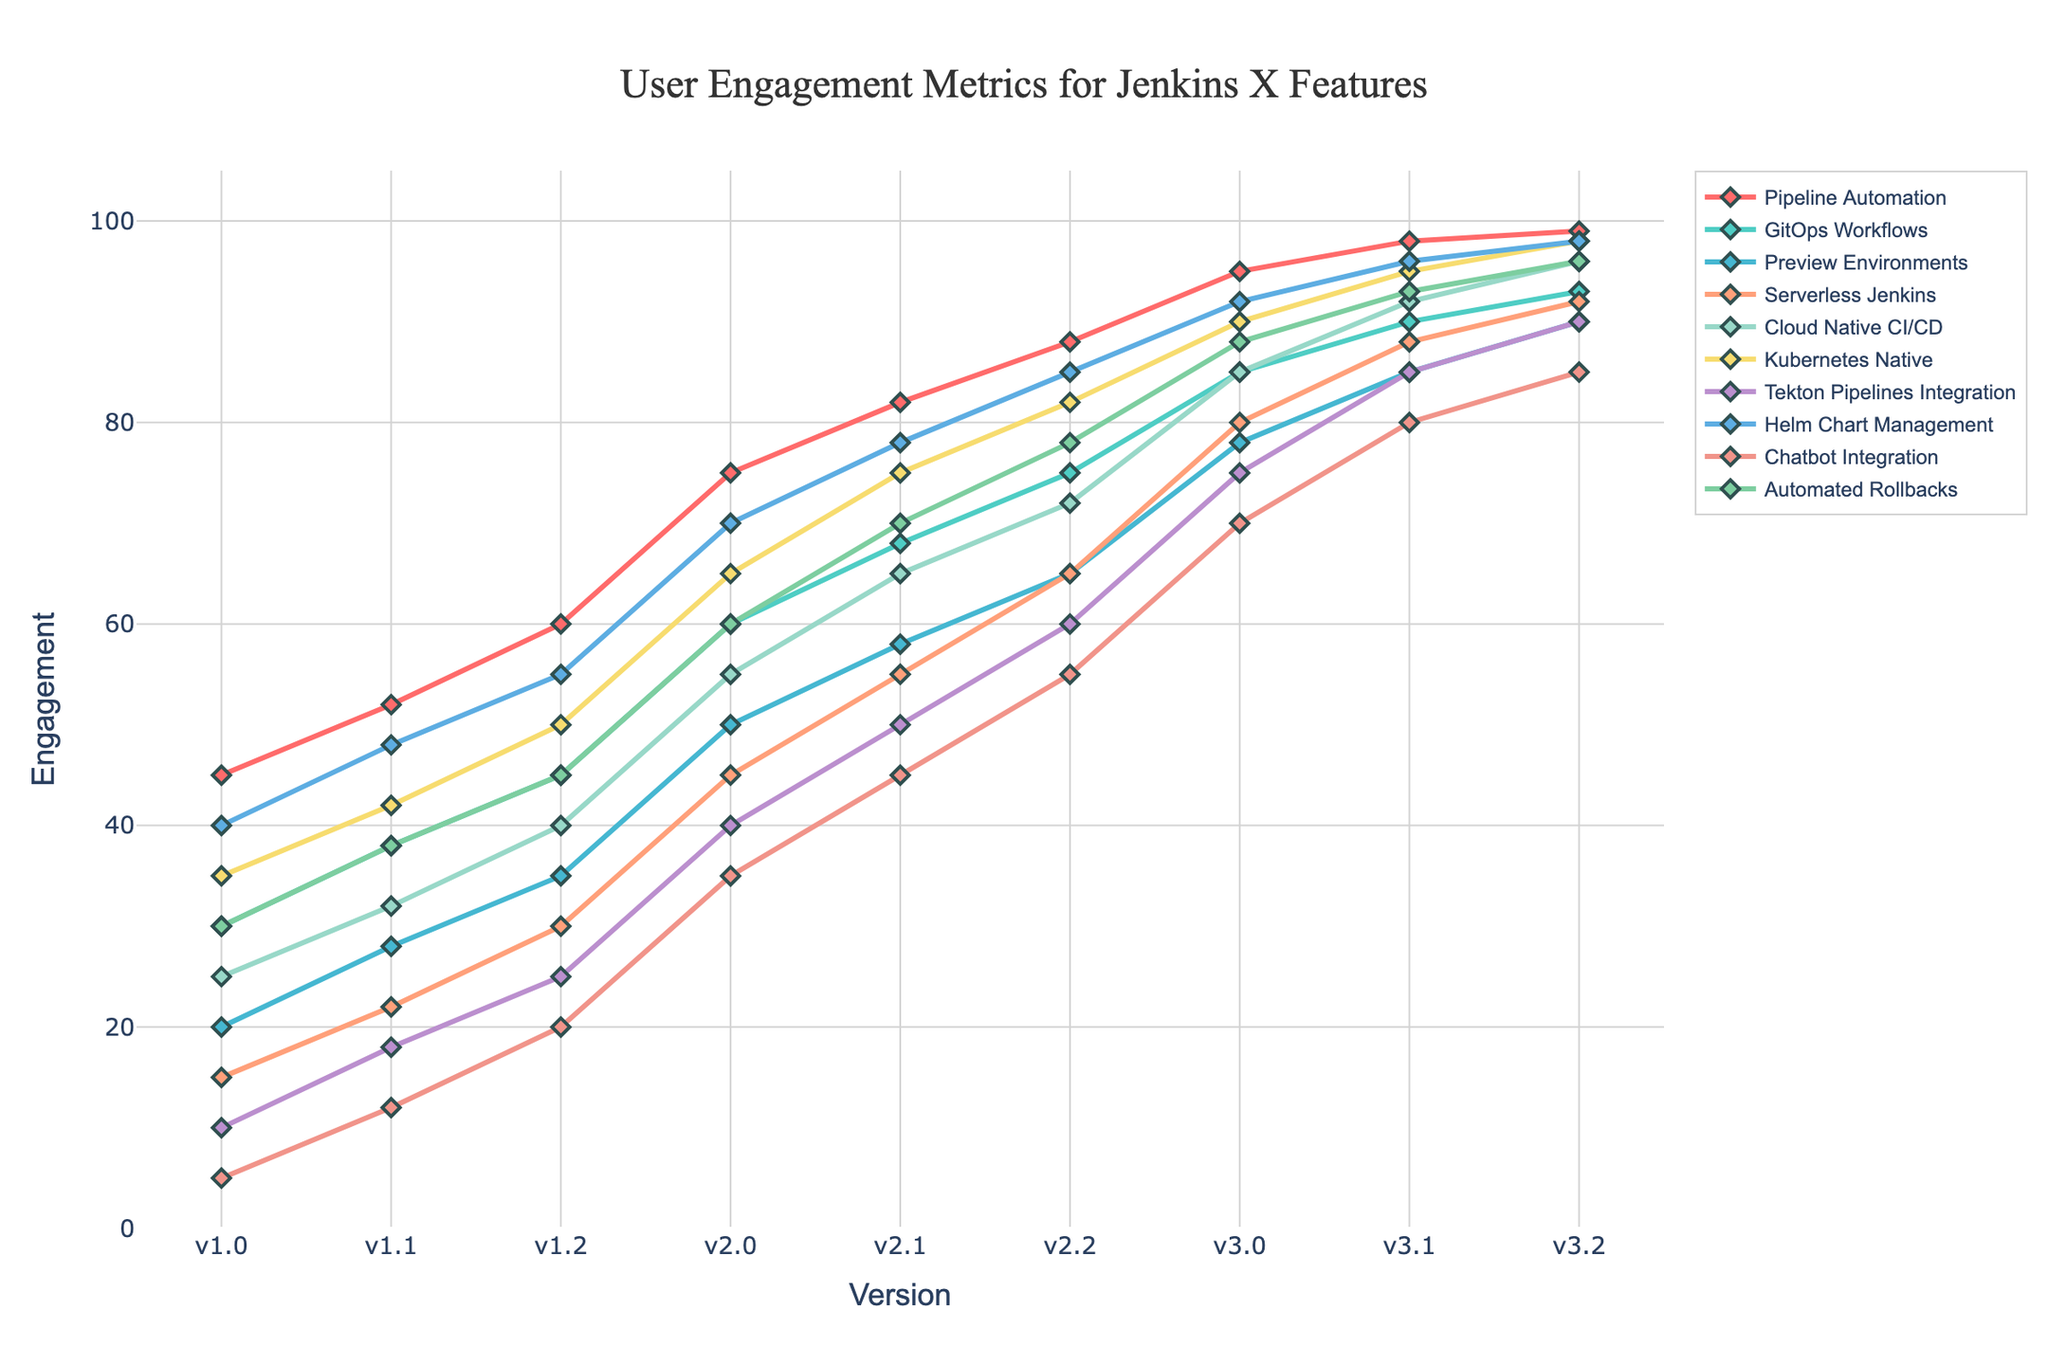What's the engagement difference between "Pipeline Automation" and "GitOps Workflows" in version v3.2? In version v3.2, "Pipeline Automation" has an engagement of 99, whereas "GitOps Workflows" has an engagement of 93. The difference between them is 99 - 93 = 6.
Answer: 6 Which feature has the highest engagement in version v2.2? To find the feature with the highest engagement in version v2.2, compare the engagement values of each feature at v2.2. The highest value is 88, for the feature "Pipeline Automation."
Answer: Pipeline Automation What is the average engagement for "Serverless Jenkins" across all versions? Add the engagement values for "Serverless Jenkins" across all versions: 15 + 22 + 30 + 45 + 55 + 65 + 80 + 88 + 92 = 492. Then, divide by the number of versions, which is 9. / 492/9 = 54.67
Answer: 54.67 What is the median engagement value for all features in version v2.2? Arrange the engagement values for version v2.2: 55, 60, 65, 72, 75, 78, 85, 85, 88, 92. The median value is the average of the 5th and 6th values, which are 75 and 78. Hence, the median is (75 + 78) / 2 = 76.5.
Answer: 76.5 Compare the engagement trends for "Tekton Pipelines Integration" and "Chatbot Integration" from versions v2.0 to v3.2. Which feature shows a larger increase? From v2.0 to v3.2, "Tekton Pipelines Integration" has engagement values of 40 and 90, which is a 90 - 40 = 50 increase. "Chatbot Integration" has engagement values of 35 and 85, which is an 85 - 35 = 50 increase. Both features show the same increase of 50.
Answer: Both show the same increase 